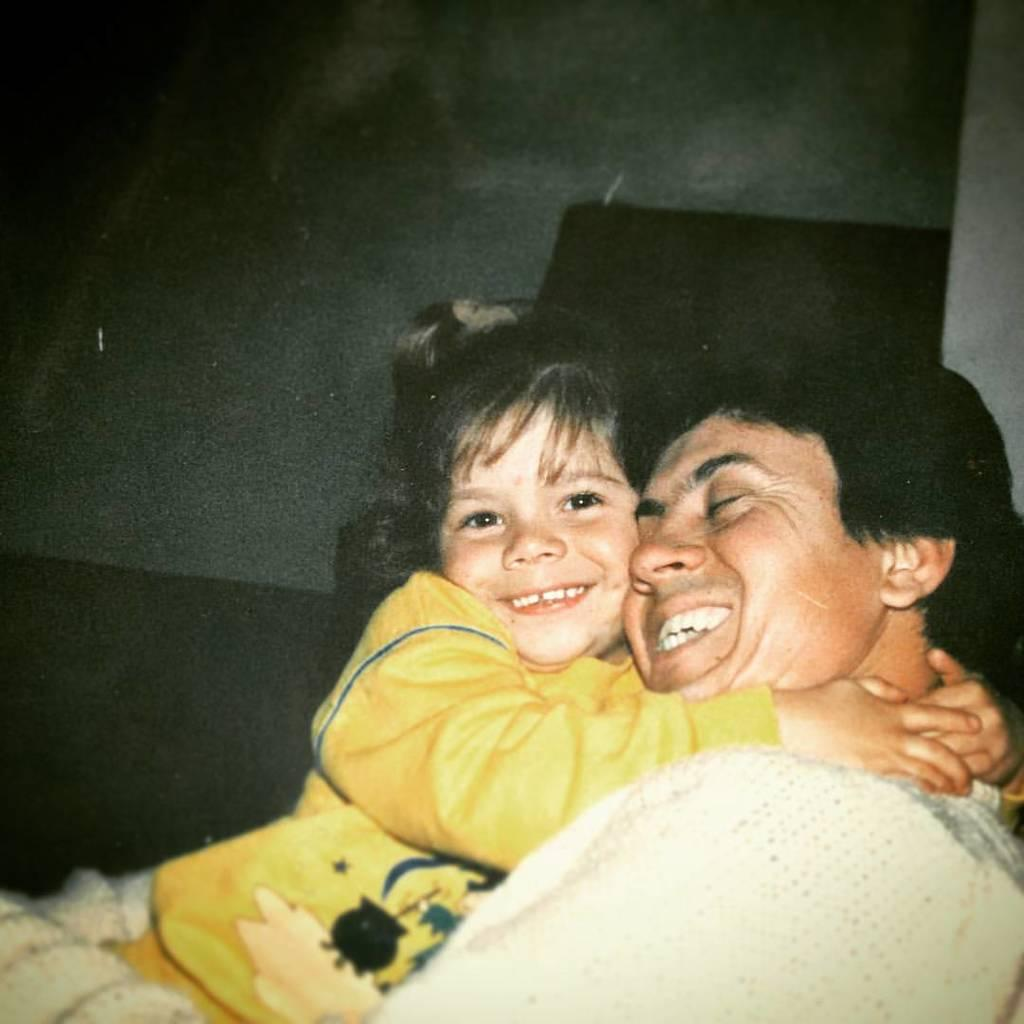Who is present in the image? There is a man and a small girl in the image. Where are the man and the small girl located in the image? They are on the right side of the image. What are the man and the small girl doing in the image? The man and the small girl are hugging each other. Can you see any ghosts in the image? No, there are no ghosts present in the image. What type of rock is the man holding in the image? There is no rock visible in the image; the man and the small girl are hugging each other. 